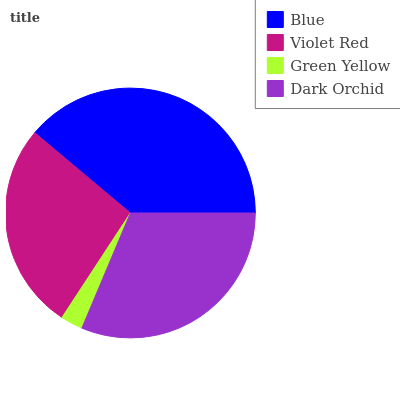Is Green Yellow the minimum?
Answer yes or no. Yes. Is Blue the maximum?
Answer yes or no. Yes. Is Violet Red the minimum?
Answer yes or no. No. Is Violet Red the maximum?
Answer yes or no. No. Is Blue greater than Violet Red?
Answer yes or no. Yes. Is Violet Red less than Blue?
Answer yes or no. Yes. Is Violet Red greater than Blue?
Answer yes or no. No. Is Blue less than Violet Red?
Answer yes or no. No. Is Dark Orchid the high median?
Answer yes or no. Yes. Is Violet Red the low median?
Answer yes or no. Yes. Is Green Yellow the high median?
Answer yes or no. No. Is Blue the low median?
Answer yes or no. No. 